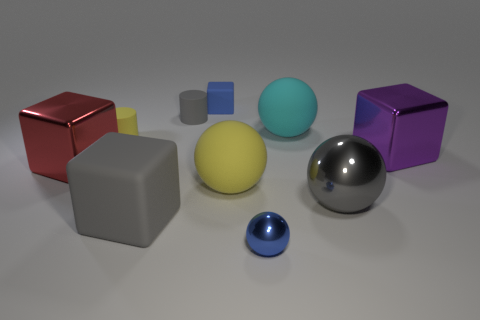What shape is the gray rubber object in front of the shiny cube on the left side of the tiny thing that is to the right of the blue matte cube?
Make the answer very short. Cube. Do the blue thing that is behind the purple shiny block and the tiny object that is in front of the big yellow rubber object have the same material?
Ensure brevity in your answer.  No. What material is the purple object?
Provide a short and direct response. Metal. How many big gray things are the same shape as the big yellow object?
Provide a succinct answer. 1. What is the material of the block that is the same color as the large shiny ball?
Make the answer very short. Rubber. Are there any other things that are the same shape as the big purple thing?
Your answer should be compact. Yes. What color is the cylinder in front of the rubber cylinder that is to the right of the gray rubber thing that is in front of the red object?
Offer a terse response. Yellow. How many small objects are spheres or purple objects?
Offer a terse response. 1. Are there the same number of matte cylinders that are behind the small blue cube and small red matte balls?
Make the answer very short. Yes. Are there any small blue shiny spheres behind the tiny blue ball?
Keep it short and to the point. No. 